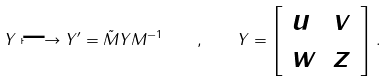<formula> <loc_0><loc_0><loc_500><loc_500>Y \longmapsto Y ^ { \prime } = \tilde { M } Y M ^ { - 1 } \quad , \quad Y = \left [ \begin{array} { l l } u & v \\ w & z \end{array} \right ] \, .</formula> 